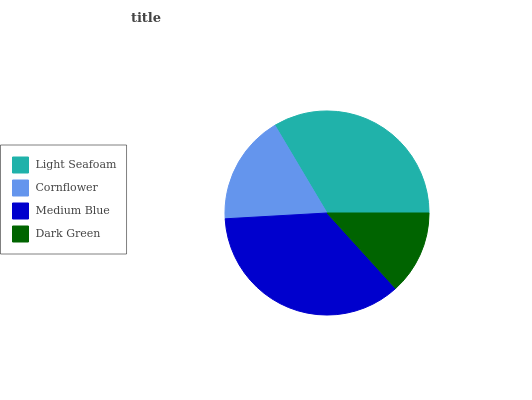Is Dark Green the minimum?
Answer yes or no. Yes. Is Medium Blue the maximum?
Answer yes or no. Yes. Is Cornflower the minimum?
Answer yes or no. No. Is Cornflower the maximum?
Answer yes or no. No. Is Light Seafoam greater than Cornflower?
Answer yes or no. Yes. Is Cornflower less than Light Seafoam?
Answer yes or no. Yes. Is Cornflower greater than Light Seafoam?
Answer yes or no. No. Is Light Seafoam less than Cornflower?
Answer yes or no. No. Is Light Seafoam the high median?
Answer yes or no. Yes. Is Cornflower the low median?
Answer yes or no. Yes. Is Dark Green the high median?
Answer yes or no. No. Is Dark Green the low median?
Answer yes or no. No. 